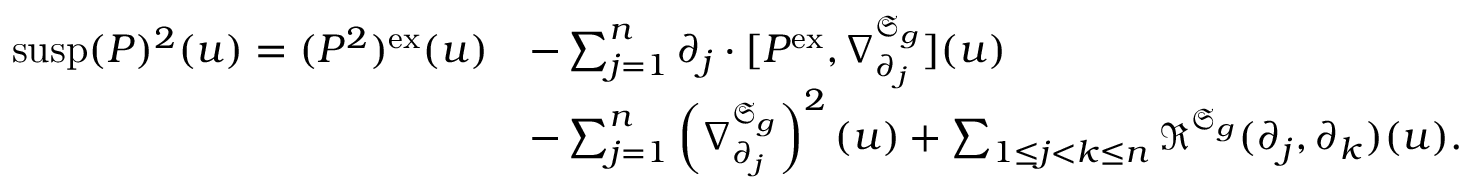<formula> <loc_0><loc_0><loc_500><loc_500>\begin{array} { r l } { s u s p ( P ) ^ { 2 } ( u ) = ( P ^ { 2 } ) ^ { e x } ( u ) } & { - \sum _ { j = 1 } ^ { n } \partial _ { j } \cdot [ P ^ { e x } , \nabla _ { \partial _ { j } } ^ { \mathfrak { S } _ { g } } ] ( u ) } \\ & { - \sum _ { j = 1 } ^ { n } \left ( \nabla _ { \partial _ { j } } ^ { \mathfrak { S } _ { g } } \right ) ^ { 2 } ( u ) + \sum _ { 1 \leq j < k \leq n } \mathfrak { R } ^ { \mathfrak { S } _ { g } } ( \partial _ { j } , \partial _ { k } ) ( u ) . } \end{array}</formula> 